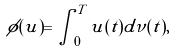<formula> <loc_0><loc_0><loc_500><loc_500>\phi ( u ) = \int _ { 0 } ^ { T } u ( t ) d \nu ( t ) ,</formula> 